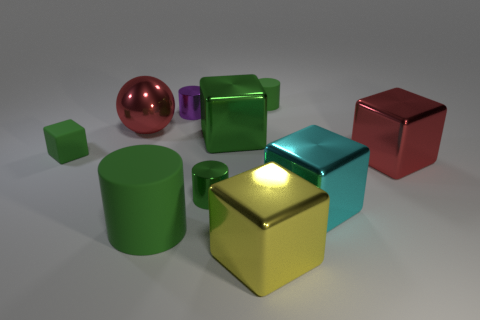Subtract all green cylinders. How many were subtracted if there are2green cylinders left? 1 Subtract all blue spheres. How many green cylinders are left? 3 Subtract all yellow cubes. How many cubes are left? 4 Subtract all red cubes. How many cubes are left? 4 Subtract 2 blocks. How many blocks are left? 3 Subtract all gray balls. Subtract all cyan cubes. How many balls are left? 1 Subtract all cylinders. How many objects are left? 6 Add 2 green things. How many green things exist? 7 Subtract 0 yellow spheres. How many objects are left? 10 Subtract all large cyan metal cubes. Subtract all cyan metal objects. How many objects are left? 8 